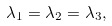Convert formula to latex. <formula><loc_0><loc_0><loc_500><loc_500>\lambda _ { 1 } = \lambda _ { 2 } = \lambda _ { 3 } ,</formula> 